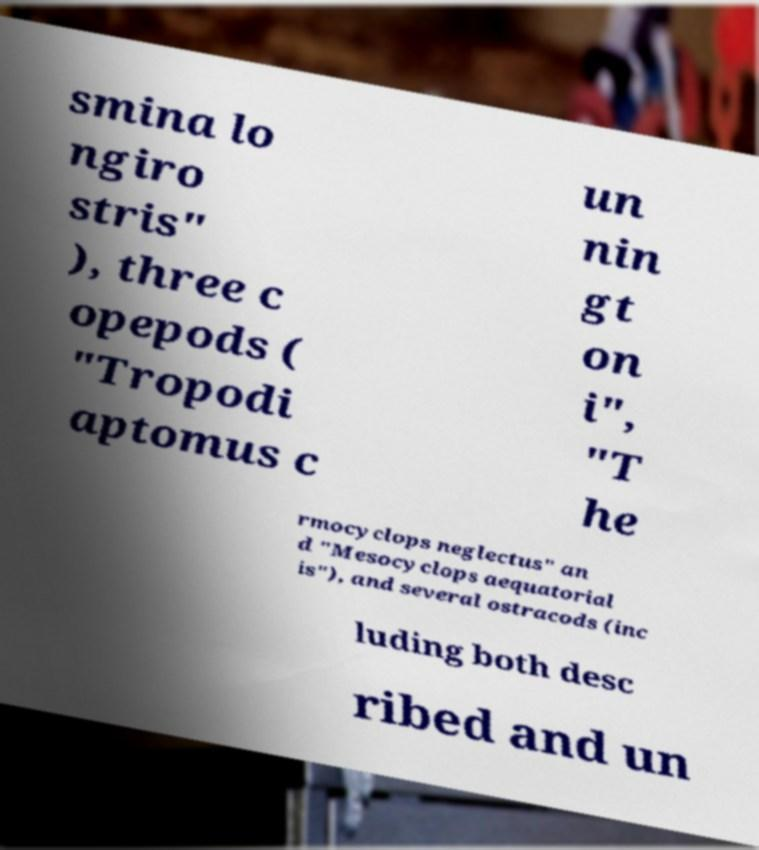For documentation purposes, I need the text within this image transcribed. Could you provide that? smina lo ngiro stris" ), three c opepods ( "Tropodi aptomus c un nin gt on i", "T he rmocyclops neglectus" an d "Mesocyclops aequatorial is"), and several ostracods (inc luding both desc ribed and un 